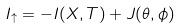Convert formula to latex. <formula><loc_0><loc_0><loc_500><loc_500>I _ { \uparrow } = - I ( X , T ) + J ( \theta , \phi )</formula> 